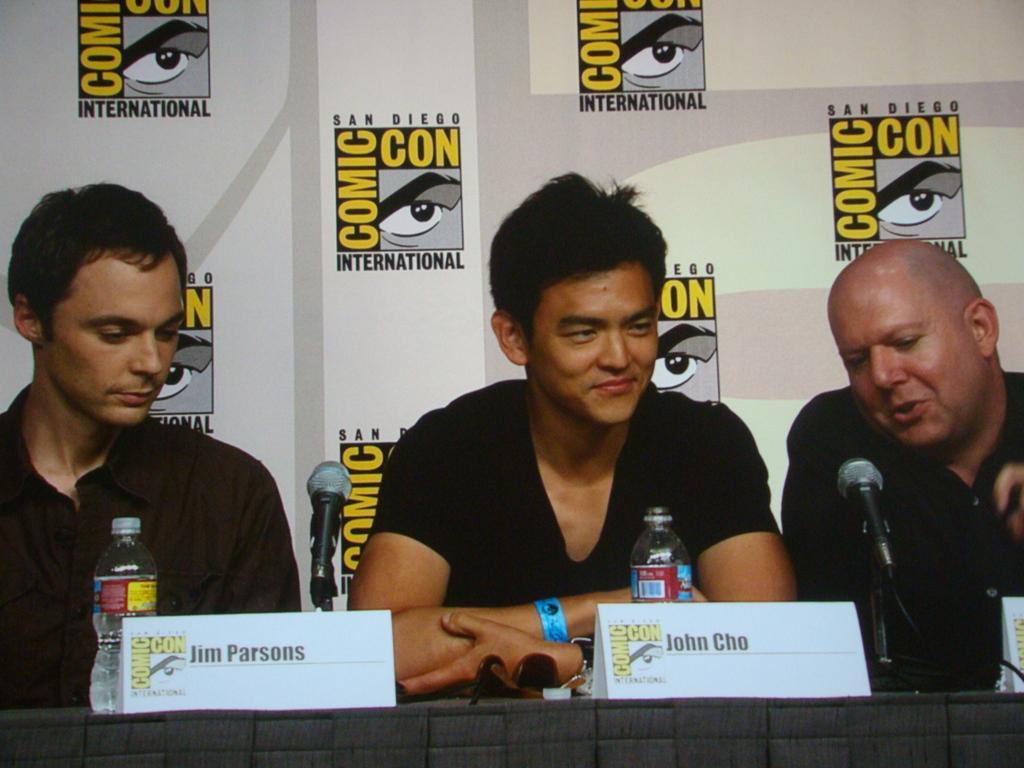Could you give a brief overview of what you see in this image? Here in this picture we can see three men sitting over a place and in front of them we can see a table, on which we can see microphones present and we can also see bottles and name cards present and all of them are smiling and behind them we can see banner present. 